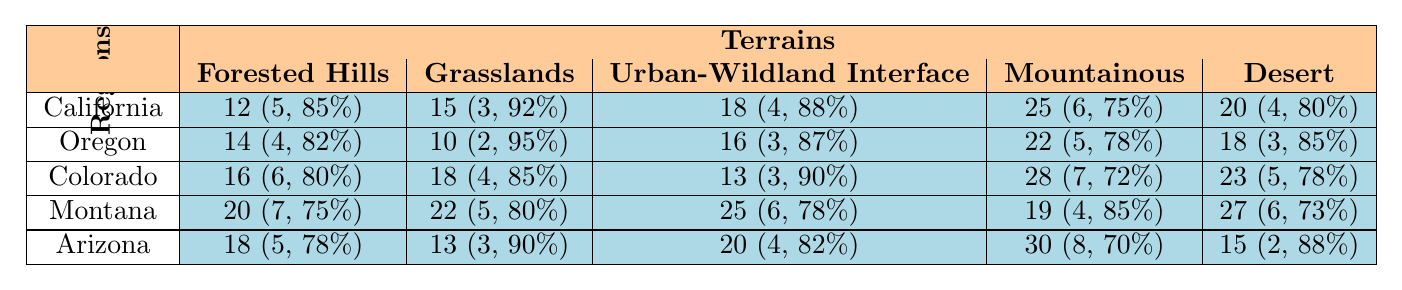What is the response time for wildfires in Oregon's Grasslands? From the table, locate Oregon in the regions column and find the response time for Grasslands, which is listed as 10.
Answer: 10 Which region has the highest response time in the Urban-Wildland Interface terrain? Reviewing the Urban-Wildland Interface column, the response times are 18 for California, 16 for Oregon, 13 for Colorado, 25 for Montana, and 20 for Arizona. The highest among these is 25 for Montana.
Answer: Montana What is the average containment success rate across all terrains in California? To find the average containment success rate for California, take the sum of the success rates (85 + 92 + 88 + 75 + 80 = 420) and divide by the number of terrains (5). Thus, the average is 420 / 5 = 84.
Answer: 84 Is the response time in Arizona's Desert terrain less than the response time in Colorado's Mountainous terrain? The response time in Arizona's Desert is 15 while in Colorado's Mountainous terrain it is 28. Since 15 is less than 28, the statement is true.
Answer: Yes What is the total number of units deployed for wildfire responses in California across all terrains? To find the total units deployed in California, sum the values in the units deployed row (5 + 3 + 4 + 6 + 4 = 22).
Answer: 22 Which region shows the lowest containment success rate in the Mountainous terrain? Check the Mountainous terrain row: California has 75, Oregon has 78, Colorado has 72, Montana has 85, and Arizona has 70. The lowest success rate is 70, which is for Arizona.
Answer: Arizona What is the difference in response times between the Forested Hills terrain in California and Montana? For California, the response time in Forested Hills is 12, and for Montana, it is 20. Calculating the difference: 20 - 12 = 8.
Answer: 8 Which terrain in Colorado had the fastest response time? In the Colorado row, response times are: 16 for Forested Hills, 18 for Grasslands, 13 for Urban-Wildland Interface, 28 for Mountainous, and 23 for Desert. The fastest response time is 13 for Urban-Wildland Interface.
Answer: Urban-Wildland Interface What is the total response time across all terrains for the region with the highest overall containment success rate? First, identify the overall success rates: California (84), Oregon (85), Colorado (82), Montana (78), Arizona (82). Oregon has the highest success rate of 85. Add its response times: 14 + 10 + 16 + 22 + 18 = 80.
Answer: 80 If the response time in Arizona's Mountainous terrain was reduced to match the California response time in the same terrain, what new average would be for Arizona’s terrains? Arizona's Mountainous terrain is currently 30, but if it matches California's 25, the new response times would be: 18, 13, 20, 25, 15. The total of these is 91, and dividing by 5 gives an average of 18.2.
Answer: 18.2 